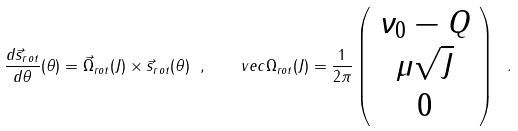<formula> <loc_0><loc_0><loc_500><loc_500>\frac { d \vec { s } _ { r o t } } { d \theta } ( \theta ) = \vec { \Omega } _ { r o t } ( J ) \times \vec { s } _ { r o t } ( \theta ) \ , \quad v e c \Omega _ { r o t } ( J ) = \frac { 1 } { 2 \pi } \left ( \begin{array} { c } \nu _ { 0 } - Q \\ \mu \sqrt { J } \\ 0 \end{array} \right ) \ .</formula> 